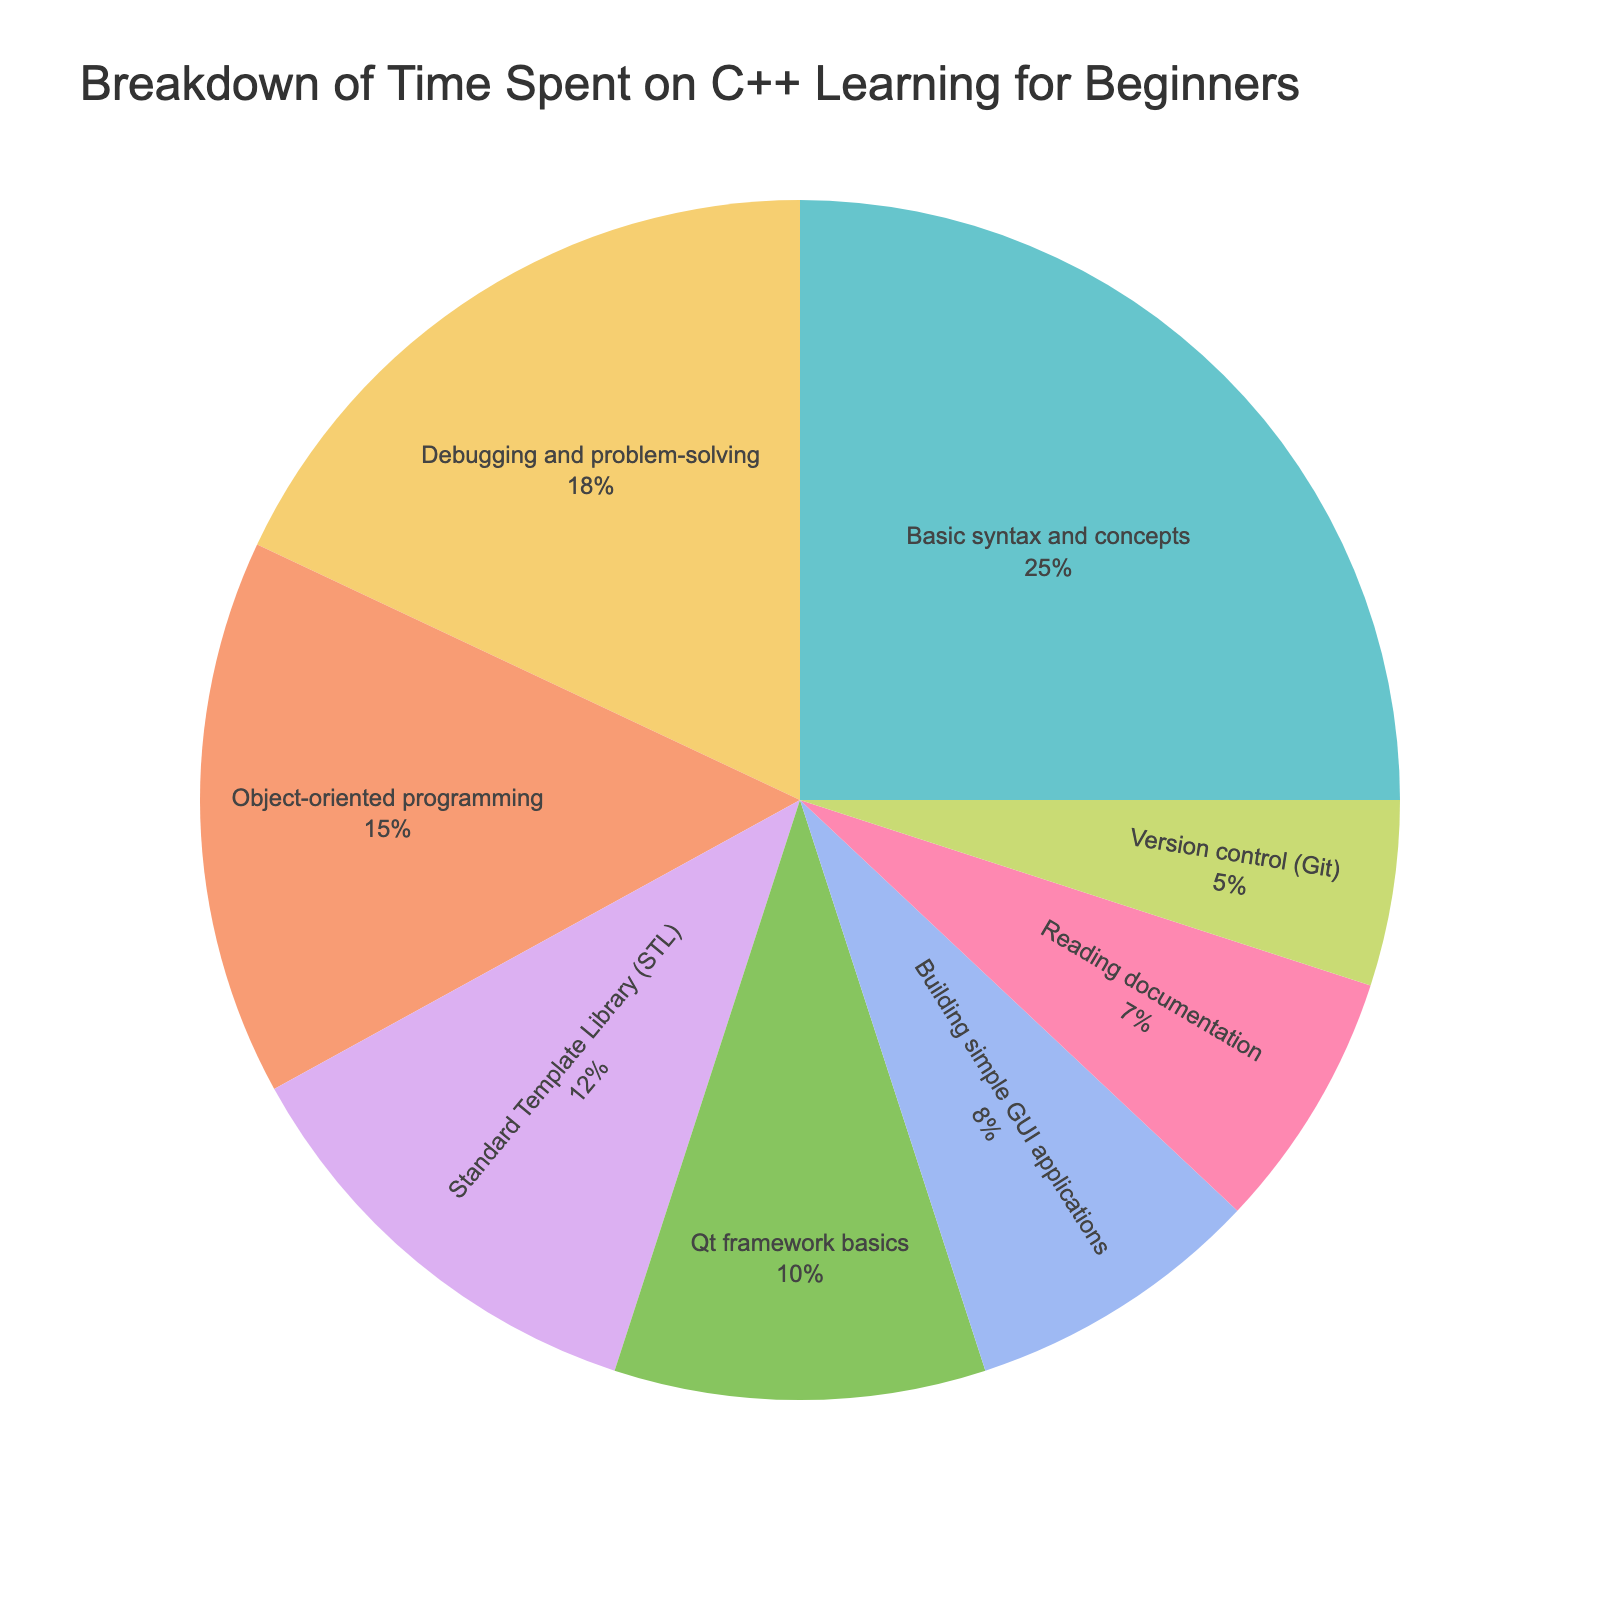What activity occupies the highest percentage of time? Basic syntax and concepts occupy 25%, which is the largest portion in the chart.
Answer: Basic syntax and concepts Which two categories take up equal time in the pie chart? Qt framework basics and Building simple GUI applications both occupy 10% and 8% respectively, they don't have equal time
Answer: None How much more time is spent on Debugging and problem-solving than on Building simple GUI applications? Debugging and problem-solving occupies 18% and Building simple GUI applications occupies 8%. The difference is 18% - 8% = 10%.
Answer: 10% What is the combined percentage of time spent on Reading documentation and Version control (Git)? Reading documentation occupies 7% and Version control (Git) occupies 5%. The combined percentage is 7% + 5% = 12%.
Answer: 12% How does the time spent on Standard Template Library (STL) compare to that on Reading documentation? Standard Template Library (STL) occupies 12% while Reading documentation occupies 7%. The STL takes up a higher percentage of time.
Answer: Higher than Reading documentation Which activity has the least amount of time dedicated to it? Version control (Git) has the least time dedicated, at 5%.
Answer: Version control (Git) Is the time spent on Object-oriented programming more or less than that spent on Basic syntax and concepts? Basic syntax and concepts occupy 25%, whereas Object-oriented programming occupies 15%. Therefore, Object-oriented programming takes up less time.
Answer: Less What percentage of time is collectively devoted to Object-oriented programming and Standard Template Library (STL)? Object-oriented programming occupies 15% and Standard Template Library (STL) occupies 12%. The combined percentage is 15% + 12% = 27%.
Answer: 27% How does the time spent on the Qt framework basics compare to the time spent on Basic syntax and concepts? Qt framework basics occupy 10%, whereas Basic syntax and concepts occupy 25%. The time spent on Qt framework basics is less.
Answer: Less Which activities are directly below the 15% mark in terms of time spent? Standard Template Library (STL), Debugging and problem-solving, Qt framework basics, Building simple GUI applications, Reading documentation, and Version control (Git) all lie below 15%.
Answer: STL, Debugging, Qt basics, GUI, Documentation, Git 